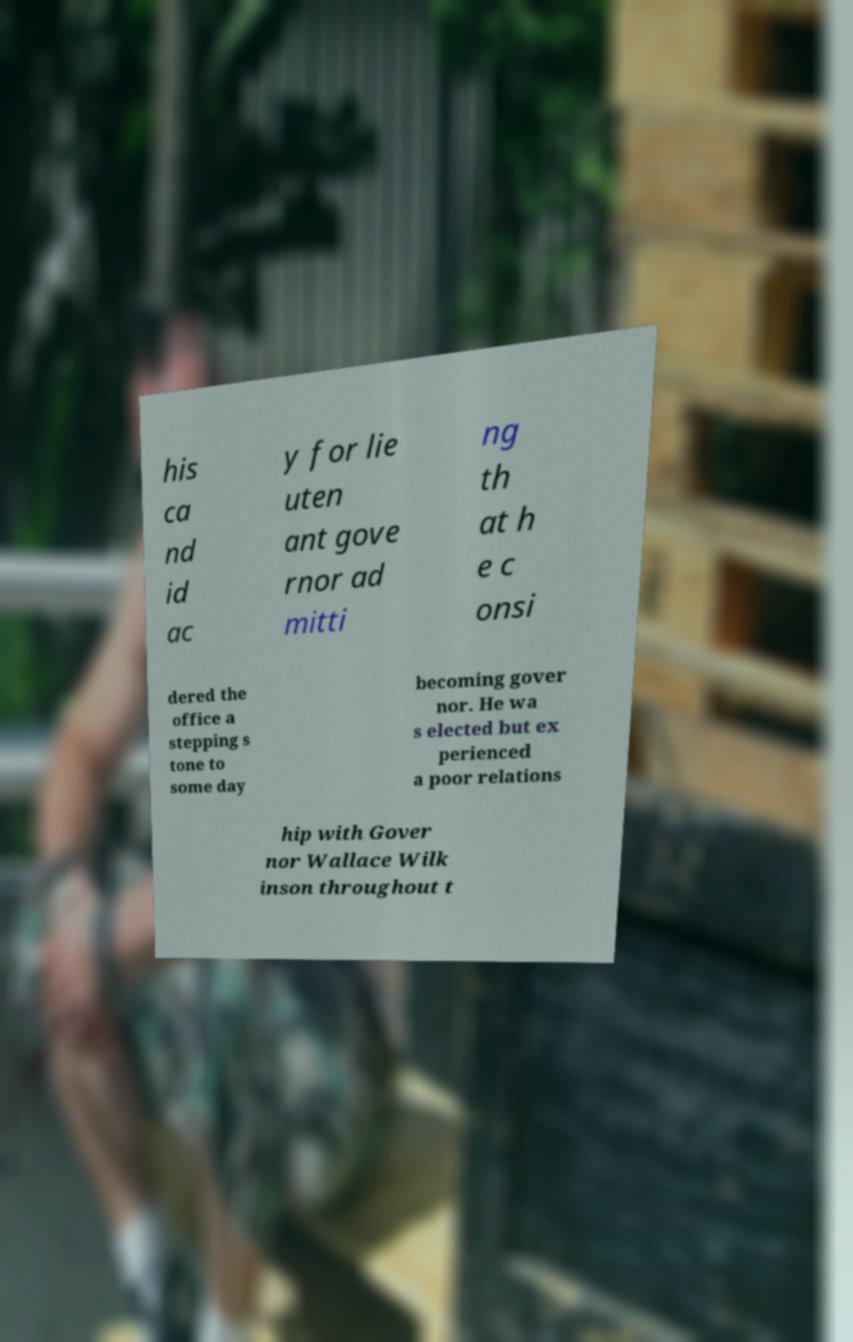I need the written content from this picture converted into text. Can you do that? his ca nd id ac y for lie uten ant gove rnor ad mitti ng th at h e c onsi dered the office a stepping s tone to some day becoming gover nor. He wa s elected but ex perienced a poor relations hip with Gover nor Wallace Wilk inson throughout t 